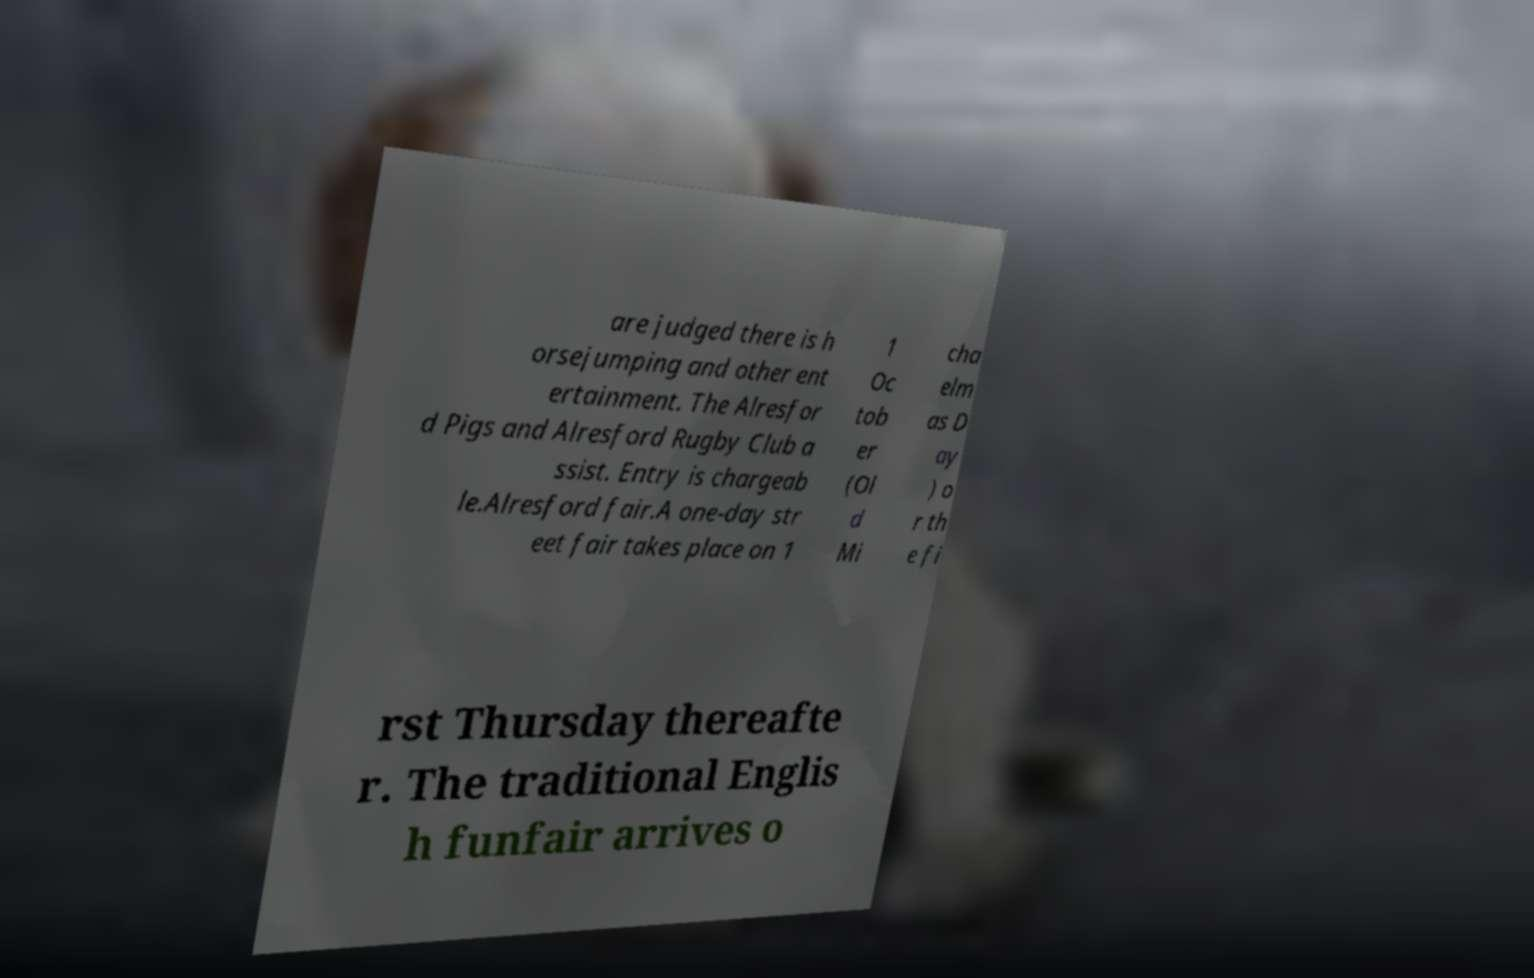Can you read and provide the text displayed in the image?This photo seems to have some interesting text. Can you extract and type it out for me? are judged there is h orsejumping and other ent ertainment. The Alresfor d Pigs and Alresford Rugby Club a ssist. Entry is chargeab le.Alresford fair.A one-day str eet fair takes place on 1 1 Oc tob er (Ol d Mi cha elm as D ay ) o r th e fi rst Thursday thereafte r. The traditional Englis h funfair arrives o 